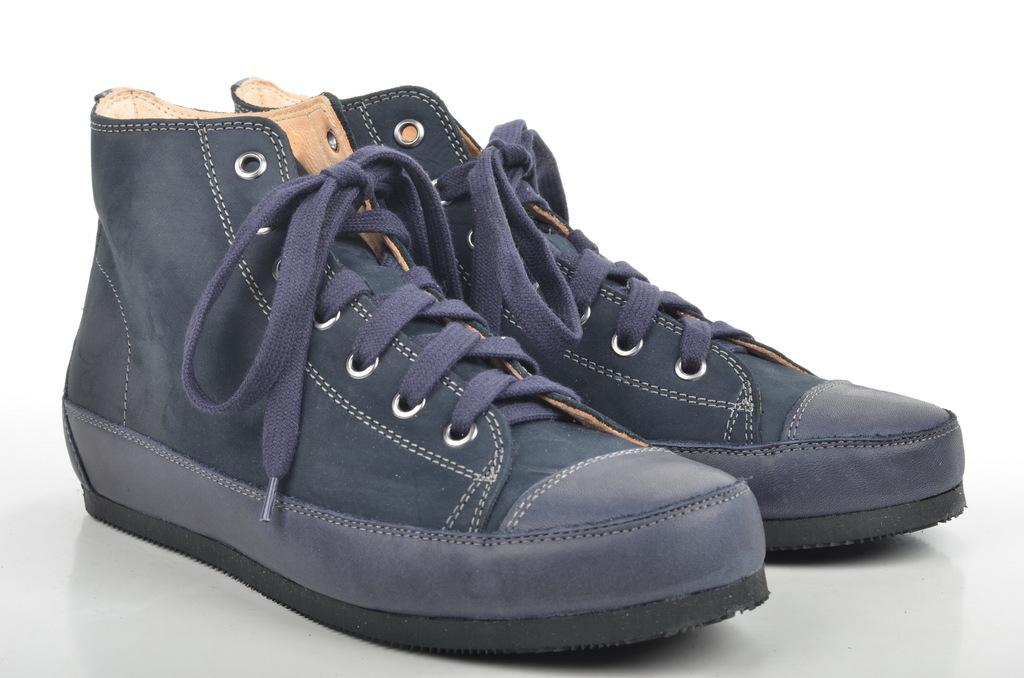What objects are present in the image? There are shoes in the image. Where are the shoes located? The shoes are on a surface. What type of eggs are being used in the religious ceremony depicted in the image? There is no religious ceremony or eggs present in the image; it only features shoes on a surface. 